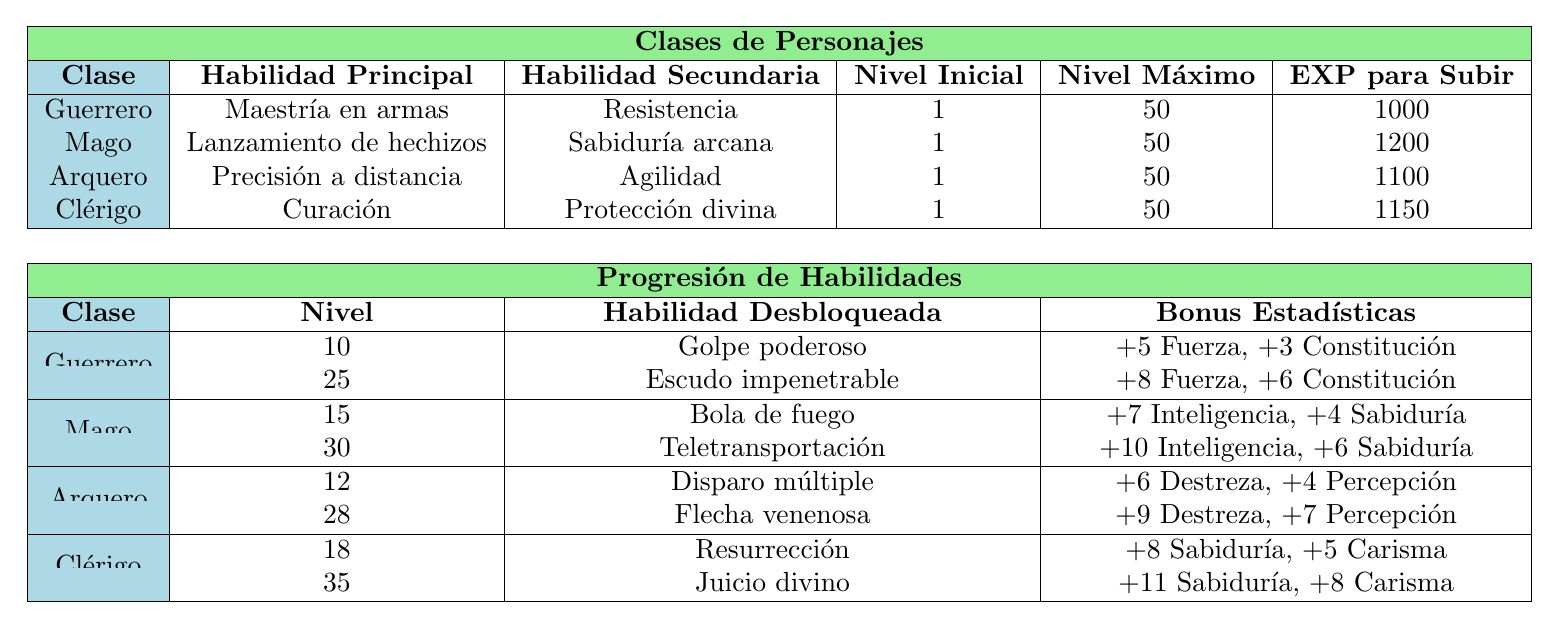¿Cuál es la habilidad principal del Guerrero? En la tabla, en la fila correspondiente a la clase Guerrero, se menciona que su habilidad principal es "Maestría en armas".
Answer: Maestría en armas ¿Cuántos niveles puede alcanzar un Mago? Al revisar la clase Mago en la tabla, se observa que su nivel máximo es 50.
Answer: 50 ¿Qué bono en estadísticas se obtiene al alcanzar el nivel 12 como Arquero? En la tabla, al alcanzar el nivel 12 como Arquero, se desbloquea la habilidad "Disparo múltiple", que otorga un bono de "+6 Destreza, +4 Percepción".
Answer: +6 Destreza, +4 Percepción ¿Un Clérigo tiene una habilidad secundaria relacionada con la curación? En la tabla, bajo la clase Clérigo, la habilidad secundaria señalada es "Protección divina", no está relacionada con la curación.
Answer: No ¿Cuál es el total de puntos de experiencia necesarios para que un Guerrero suba hasta el nivel 25? Para calcular esto, debemos sumar los puntos de experiencia requeridos para subir de nivel desde 1 hasta 25. Desde el nivel 1 al 25 son 24 niveles, multiplicando 24 x 1000 = 24000.
Answer: 24000 ¿A qué nivel se desbloquea la habilidad "Flecha venenosa" para el Arquero? Revisando la tabla, la habilidad "Flecha venenosa" se desbloquea cuando el Arquero alcanza el nivel 28.
Answer: 28 ¿Cuál es la habilidad desbloqueada en el nivel 35 del Clérigo? En la tabla, al verificar el nivel 35 del Clérigo, se menciona que la habilidad desbloqueada es "Juicio divino".
Answer: Juicio divino ¿Qué clase tiene el bono más alto en estadísticas y cuántos es? Al analizar cada clase y sus habilidades desbloqueadas, el bono más alto es de "+11 Sabiduría, +8 Carisma" que corresponde al Clérigo en el nivel 35.
Answer: Clérigo, +11 Sabiduría, +8 Carisma ¿Es cierto que el Mago tiene más puntos de experiencia requeridos que el Guerrero para subir de nivel? En la tabla, se observa que el Mago necesita 1200 puntos de experiencia por nivel, mientras que el Guerrero necesita 1000. Por lo tanto, es cierto que el Mago requiere más.
Answer: Sí ¿A qué nivel se desbloquea la habilidad "Escudo impenetrable" para el Guerrero? En la tabla, se puede ver que la habilidad "Escudo impenetrable" se desbloquea al alcanzar el nivel 25 como Guerrero.
Answer: 25 